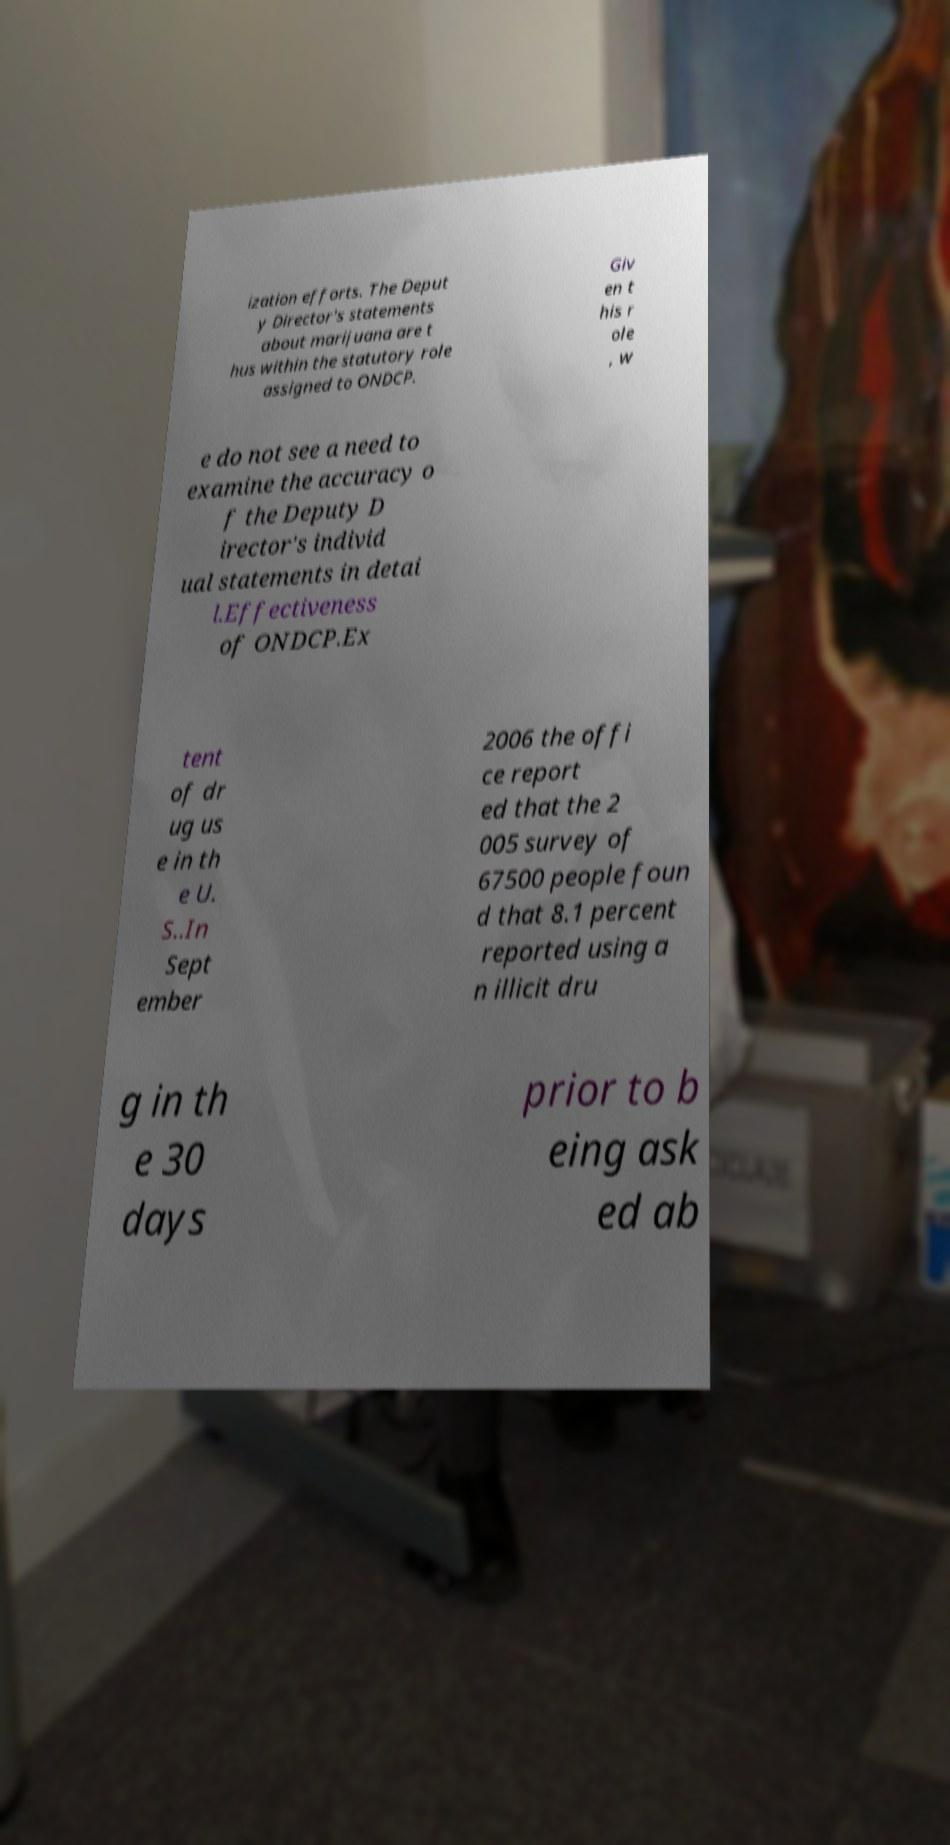Could you assist in decoding the text presented in this image and type it out clearly? ization efforts. The Deput y Director's statements about marijuana are t hus within the statutory role assigned to ONDCP. Giv en t his r ole , w e do not see a need to examine the accuracy o f the Deputy D irector's individ ual statements in detai l.Effectiveness of ONDCP.Ex tent of dr ug us e in th e U. S..In Sept ember 2006 the offi ce report ed that the 2 005 survey of 67500 people foun d that 8.1 percent reported using a n illicit dru g in th e 30 days prior to b eing ask ed ab 